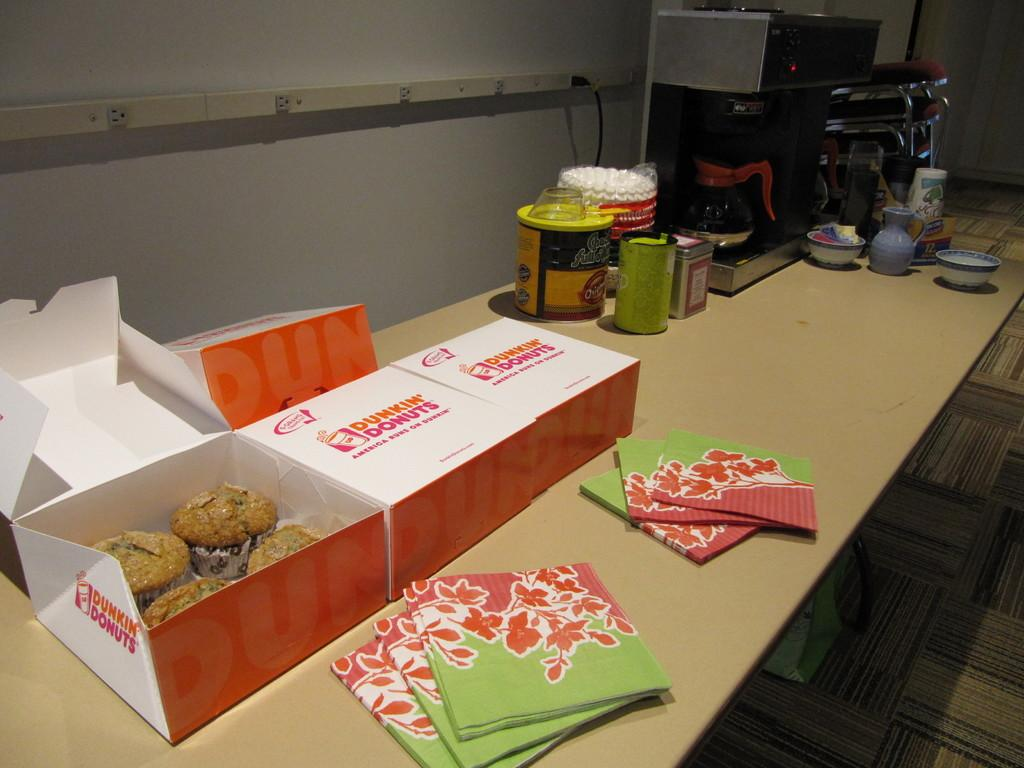Provide a one-sentence caption for the provided image. Dunkin' Donuts and refreshments are laid out on a table for patrons. 